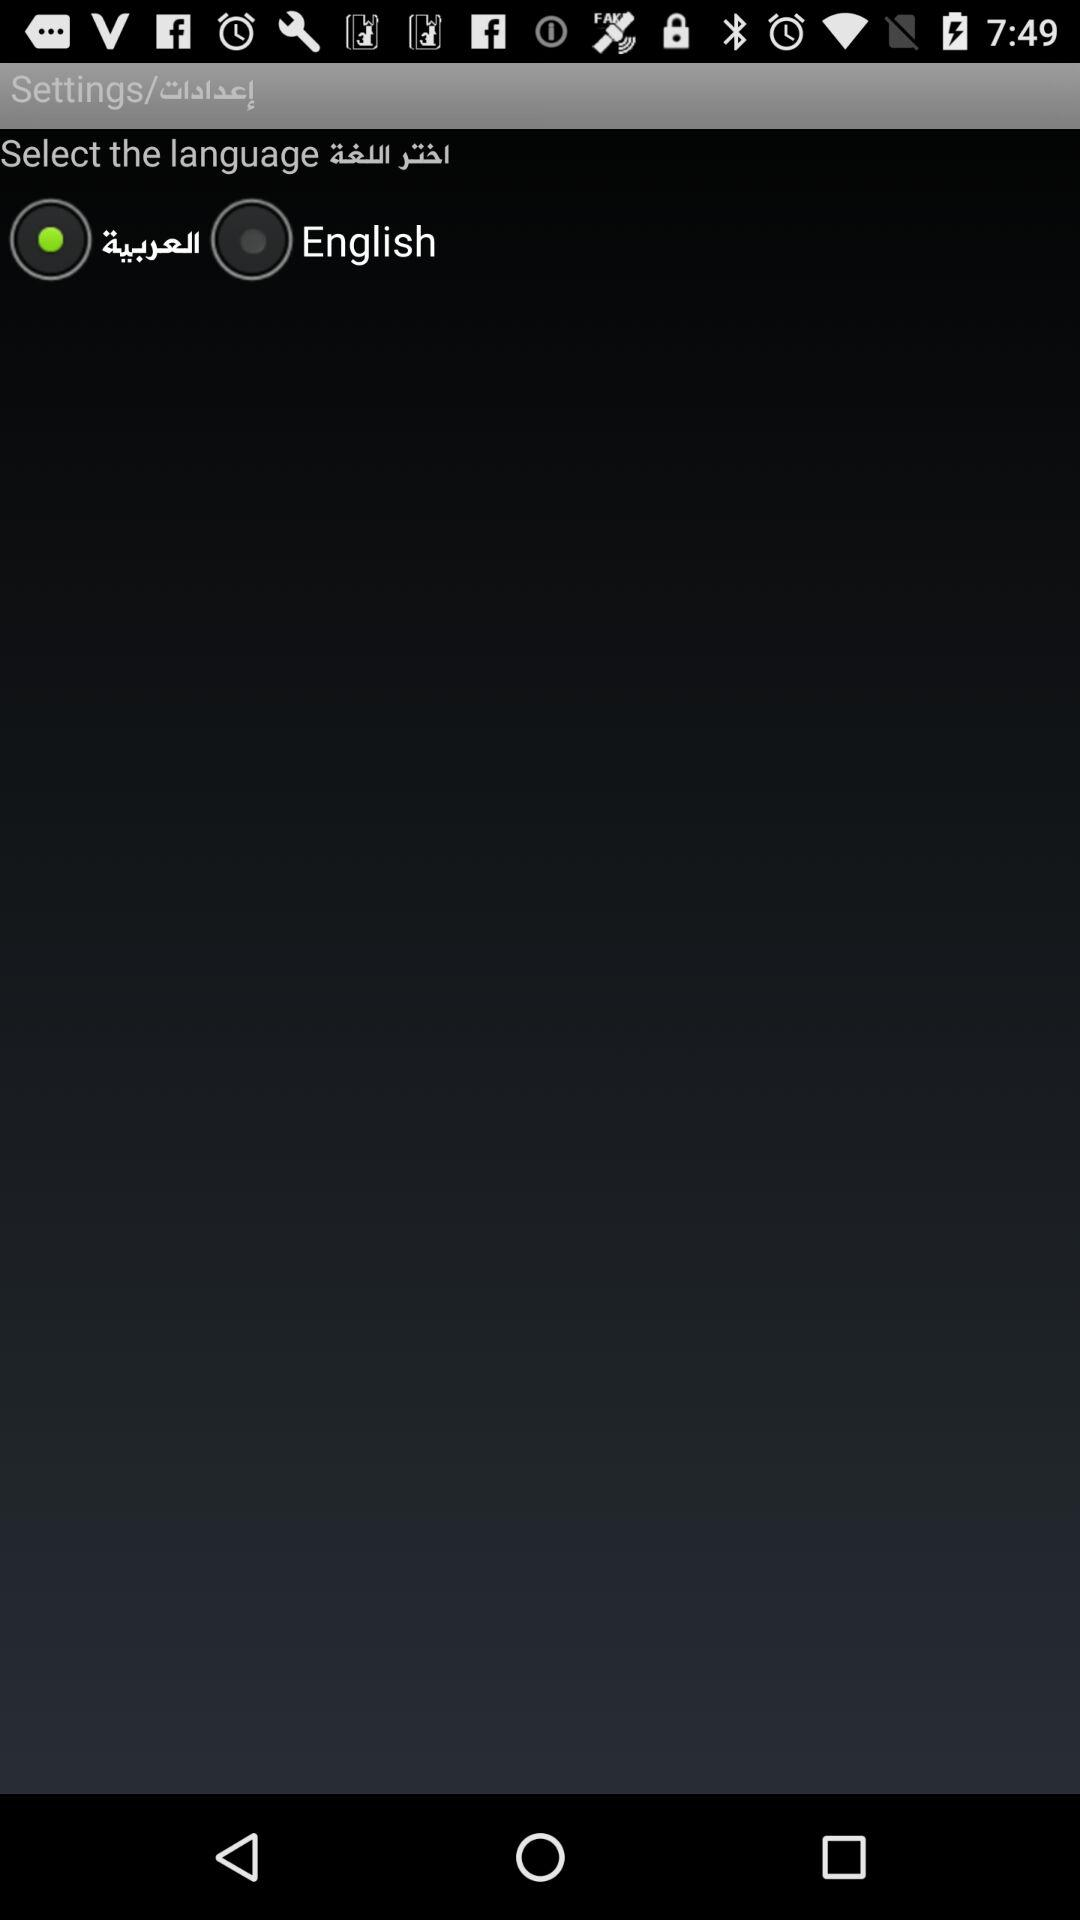How many languages are available to select from?
Answer the question using a single word or phrase. 2 